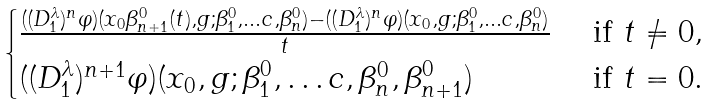Convert formula to latex. <formula><loc_0><loc_0><loc_500><loc_500>\begin{cases} \frac { ( ( D ^ { \lambda } _ { 1 } ) ^ { n } \varphi ) ( x _ { 0 } \beta ^ { 0 } _ { n + 1 } ( t ) , g ; \beta ^ { 0 } _ { 1 } , \dots c , \beta ^ { 0 } _ { n } ) - ( ( D ^ { \lambda } _ { 1 } ) ^ { n } \varphi ) ( x _ { 0 } , g ; \beta ^ { 0 } _ { 1 } , \dots c , \beta ^ { 0 } _ { n } ) } { t } & \text { if } t \neq 0 , \\ ( ( D ^ { \lambda } _ { 1 } ) ^ { n + 1 } \varphi ) ( x _ { 0 } , g ; \beta ^ { 0 } _ { 1 } , \dots c , \beta ^ { 0 } _ { n } , \beta ^ { 0 } _ { n + 1 } ) & \text { if } t = 0 . \end{cases}</formula> 